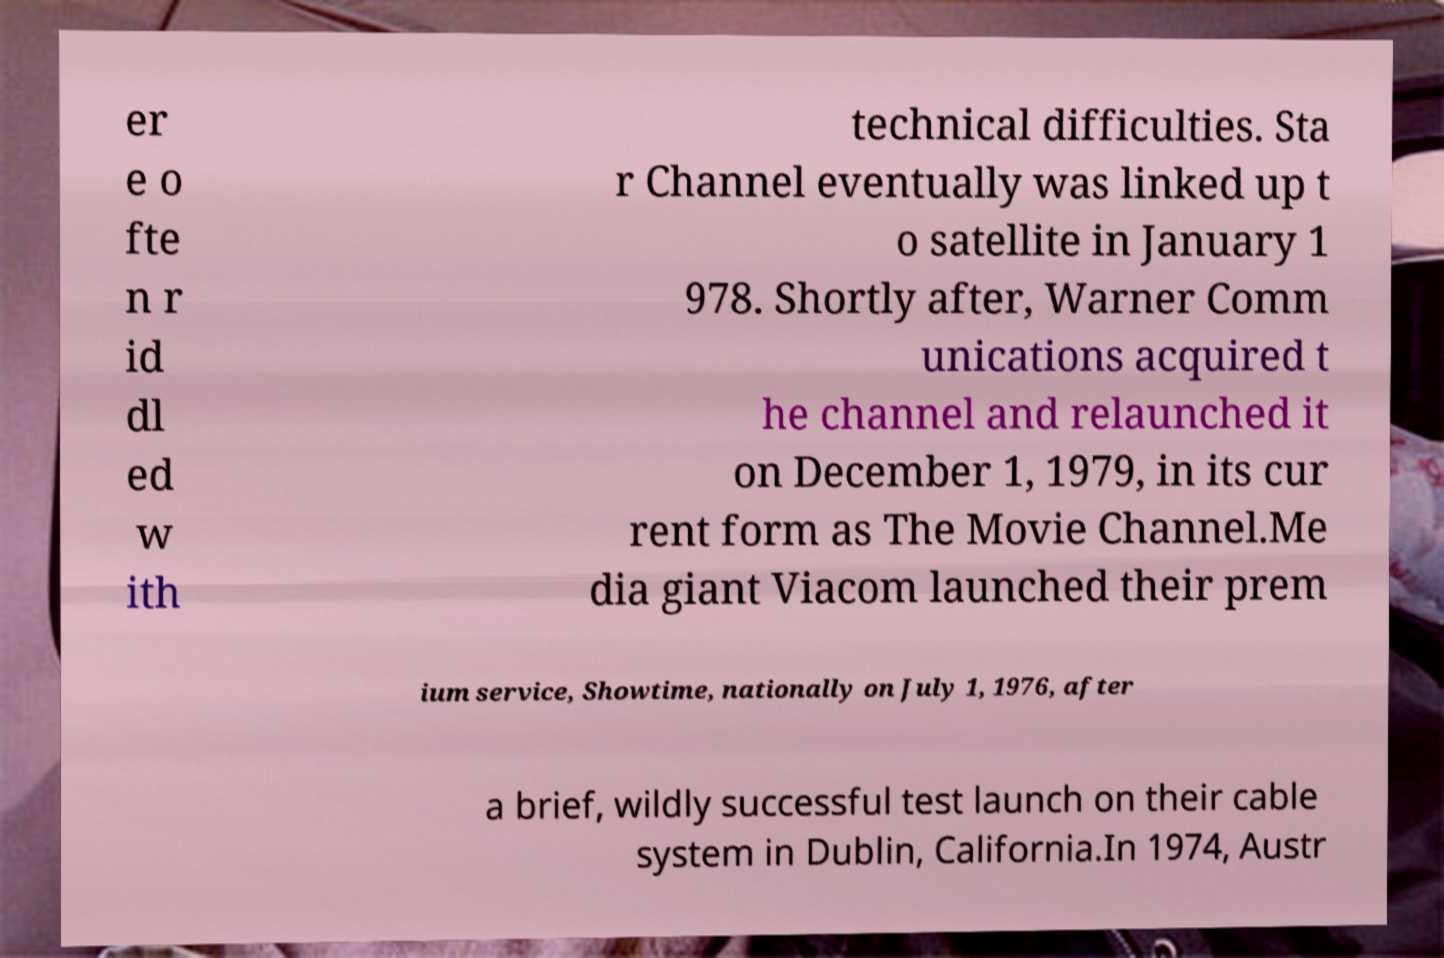For documentation purposes, I need the text within this image transcribed. Could you provide that? er e o fte n r id dl ed w ith technical difficulties. Sta r Channel eventually was linked up t o satellite in January 1 978. Shortly after, Warner Comm unications acquired t he channel and relaunched it on December 1, 1979, in its cur rent form as The Movie Channel.Me dia giant Viacom launched their prem ium service, Showtime, nationally on July 1, 1976, after a brief, wildly successful test launch on their cable system in Dublin, California.In 1974, Austr 